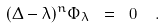Convert formula to latex. <formula><loc_0><loc_0><loc_500><loc_500>( \Delta - \lambda ) ^ { n } \Phi _ { \lambda } \ = \ 0 \ \ .</formula> 